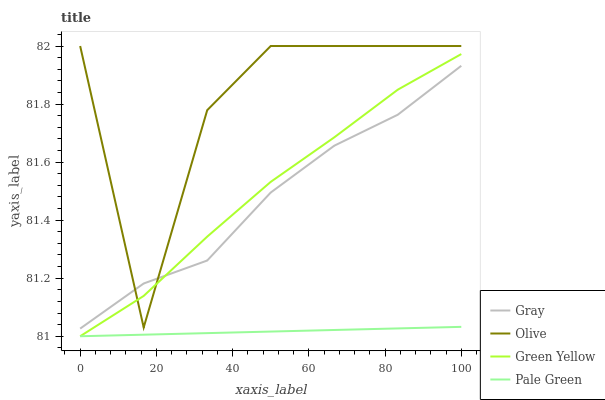Does Pale Green have the minimum area under the curve?
Answer yes or no. Yes. Does Olive have the maximum area under the curve?
Answer yes or no. Yes. Does Gray have the minimum area under the curve?
Answer yes or no. No. Does Gray have the maximum area under the curve?
Answer yes or no. No. Is Pale Green the smoothest?
Answer yes or no. Yes. Is Olive the roughest?
Answer yes or no. Yes. Is Gray the smoothest?
Answer yes or no. No. Is Gray the roughest?
Answer yes or no. No. Does Pale Green have the lowest value?
Answer yes or no. Yes. Does Gray have the lowest value?
Answer yes or no. No. Does Olive have the highest value?
Answer yes or no. Yes. Does Gray have the highest value?
Answer yes or no. No. Is Pale Green less than Gray?
Answer yes or no. Yes. Is Gray greater than Pale Green?
Answer yes or no. Yes. Does Olive intersect Green Yellow?
Answer yes or no. Yes. Is Olive less than Green Yellow?
Answer yes or no. No. Is Olive greater than Green Yellow?
Answer yes or no. No. Does Pale Green intersect Gray?
Answer yes or no. No. 